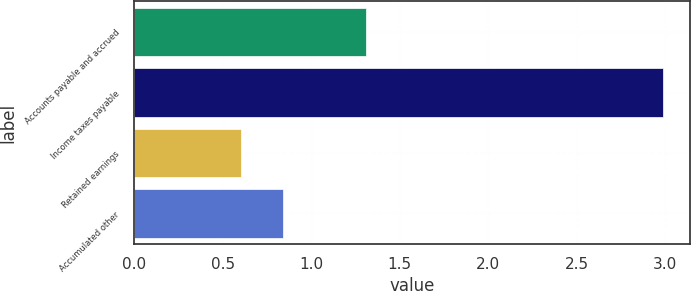<chart> <loc_0><loc_0><loc_500><loc_500><bar_chart><fcel>Accounts payable and accrued<fcel>Income taxes payable<fcel>Retained earnings<fcel>Accumulated other<nl><fcel>1.31<fcel>2.99<fcel>0.6<fcel>0.84<nl></chart> 